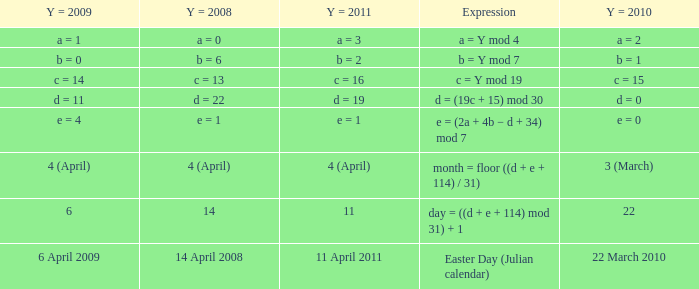Can you give me this table as a dict? {'header': ['Y = 2009', 'Y = 2008', 'Y = 2011', 'Expression', 'Y = 2010'], 'rows': [['a = 1', 'a = 0', 'a = 3', 'a = Y mod 4', 'a = 2'], ['b = 0', 'b = 6', 'b = 2', 'b = Y mod 7', 'b = 1'], ['c = 14', 'c = 13', 'c = 16', 'c = Y mod 19', 'c = 15'], ['d = 11', 'd = 22', 'd = 19', 'd = (19c + 15) mod 30', 'd = 0'], ['e = 4', 'e = 1', 'e = 1', 'e = (2a + 4b − d + 34) mod 7', 'e = 0'], ['4 (April)', '4 (April)', '4 (April)', 'month = floor ((d + e + 114) / 31)', '3 (March)'], ['6', '14', '11', 'day = ((d + e + 114) mod 31) + 1', '22'], ['6 April 2009', '14 April 2008', '11 April 2011', 'Easter Day (Julian calendar)', '22 March 2010']]} What is the y = 2008 when the expression is easter day (julian calendar)? 14 April 2008. 